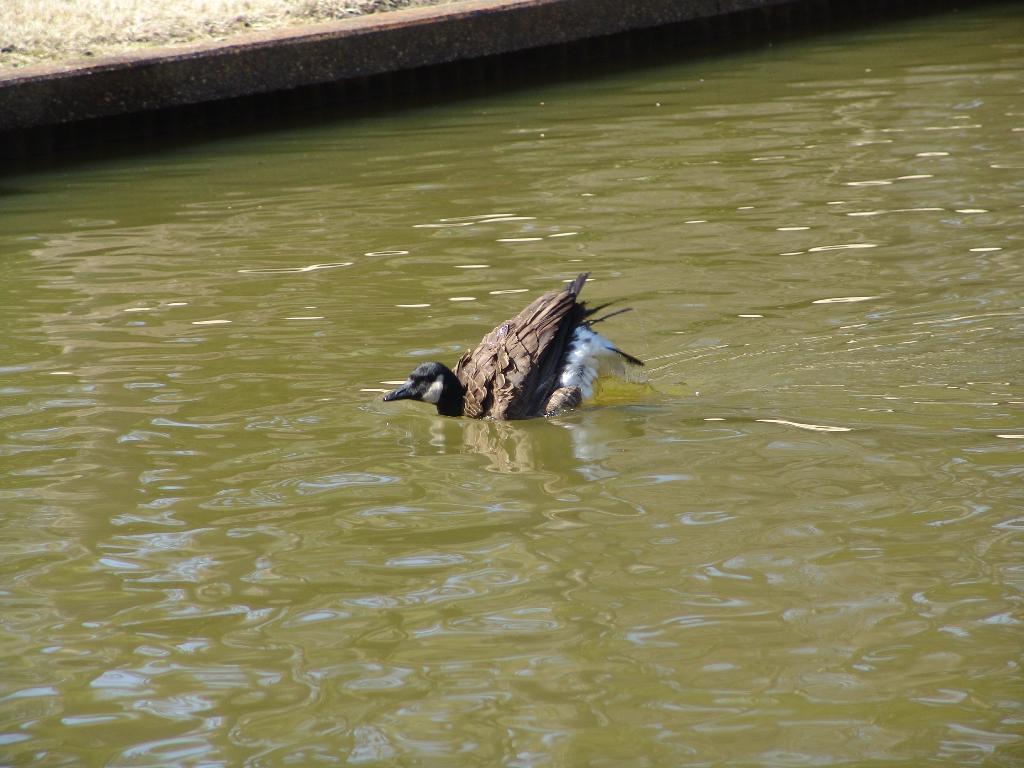Could you give a brief overview of what you see in this image? In this image we can see a bird on the water. At the top we can see grass on the ground. 